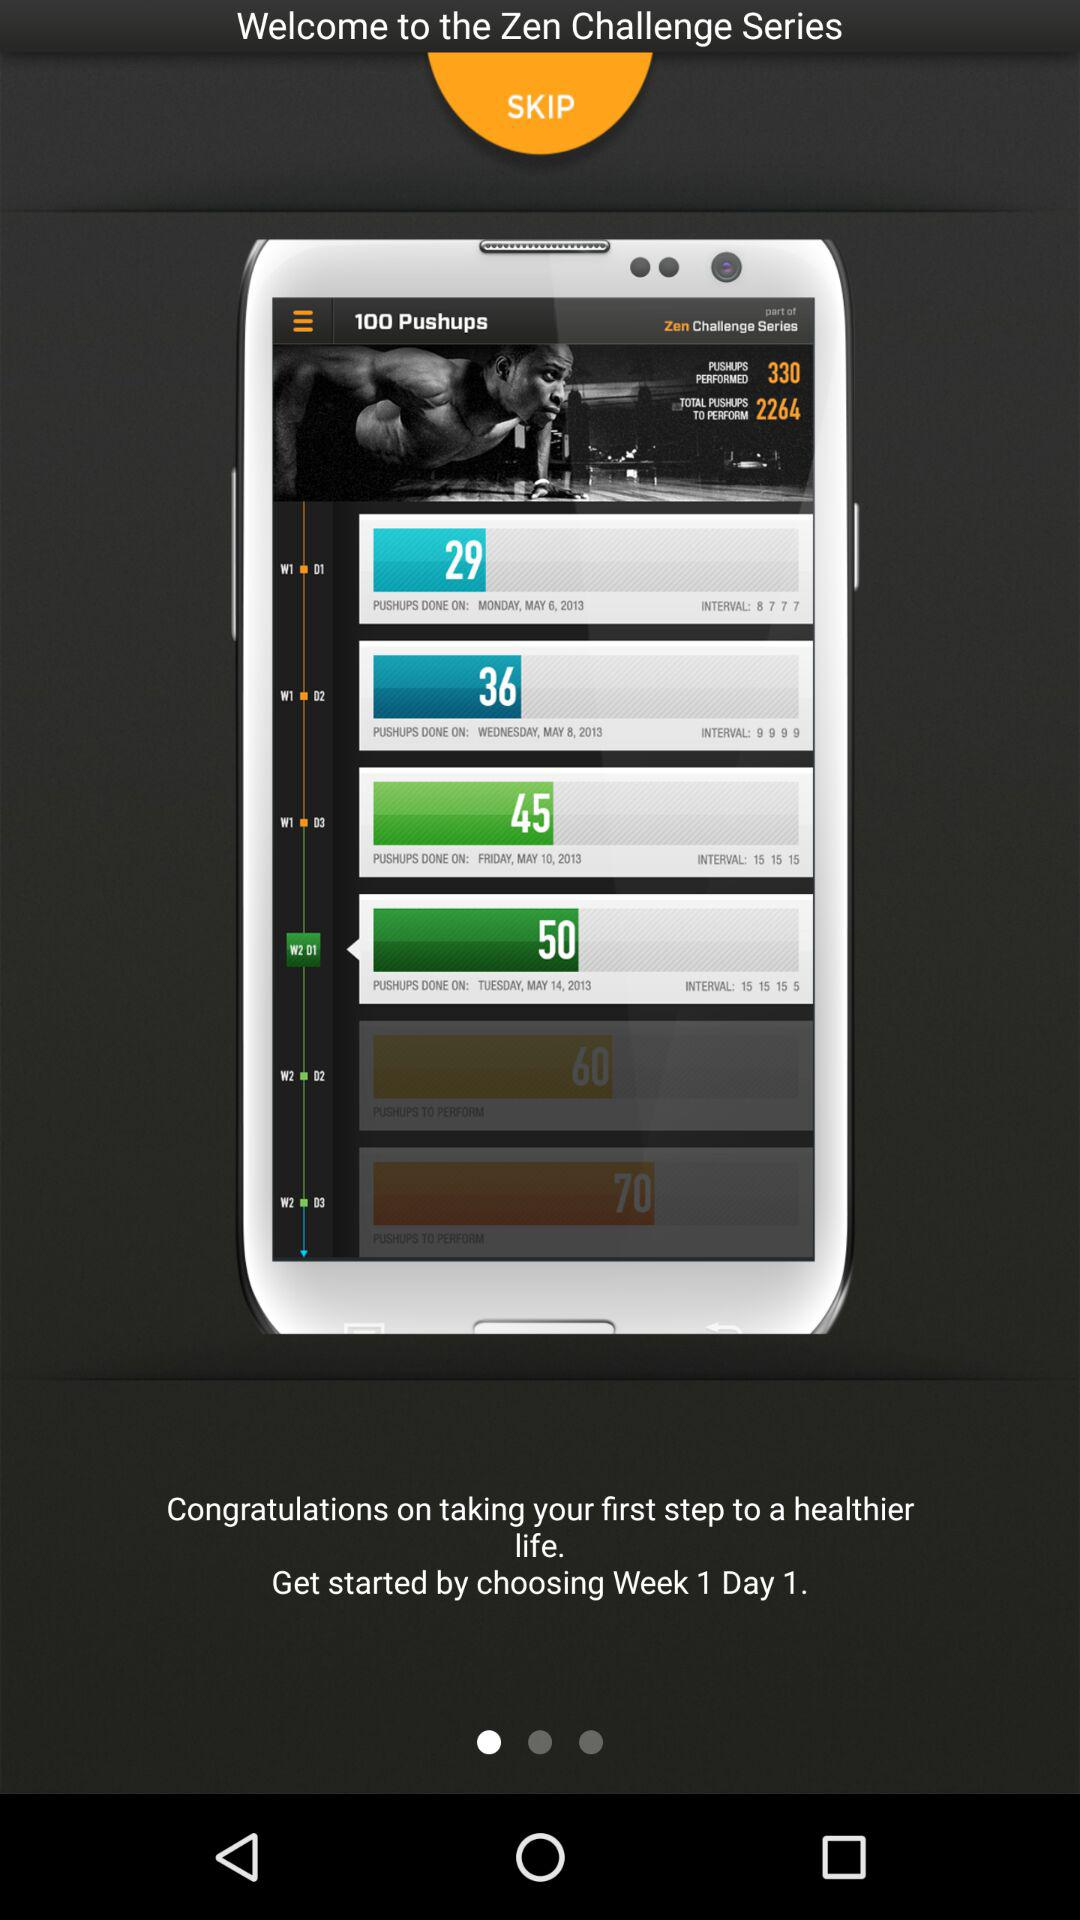How many pushups are shown here? There are 100 pushups. 